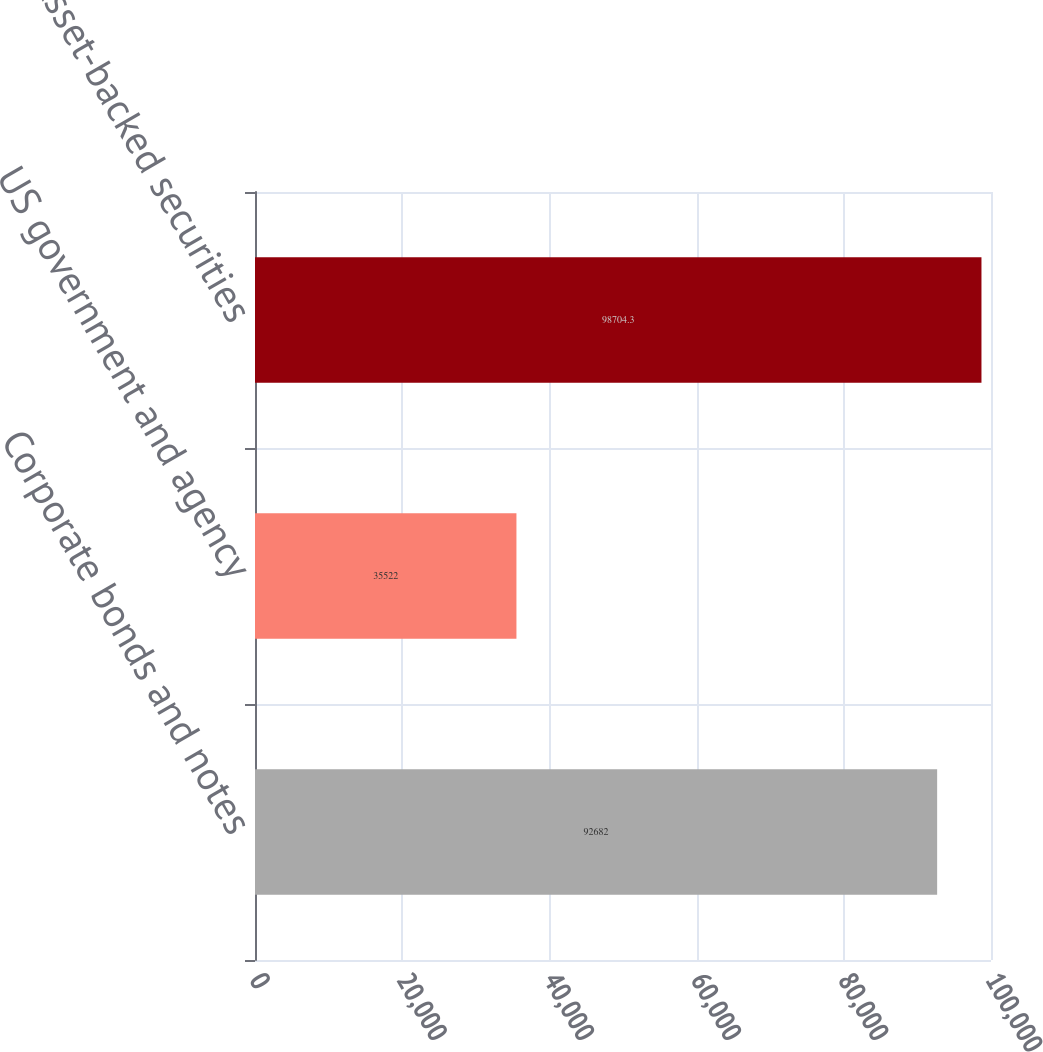<chart> <loc_0><loc_0><loc_500><loc_500><bar_chart><fcel>Corporate bonds and notes<fcel>US government and agency<fcel>Asset-backed securities<nl><fcel>92682<fcel>35522<fcel>98704.3<nl></chart> 